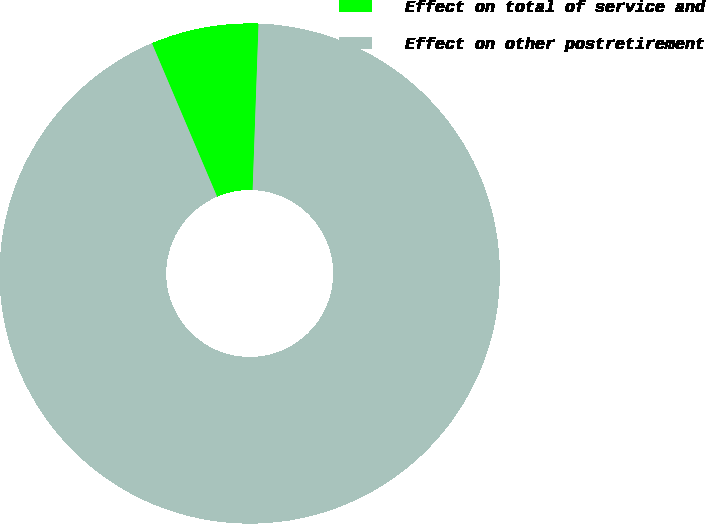<chart> <loc_0><loc_0><loc_500><loc_500><pie_chart><fcel>Effect on total of service and<fcel>Effect on other postretirement<nl><fcel>6.96%<fcel>93.04%<nl></chart> 